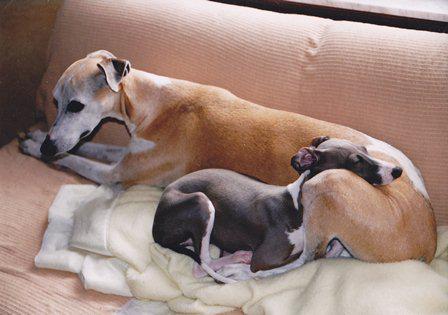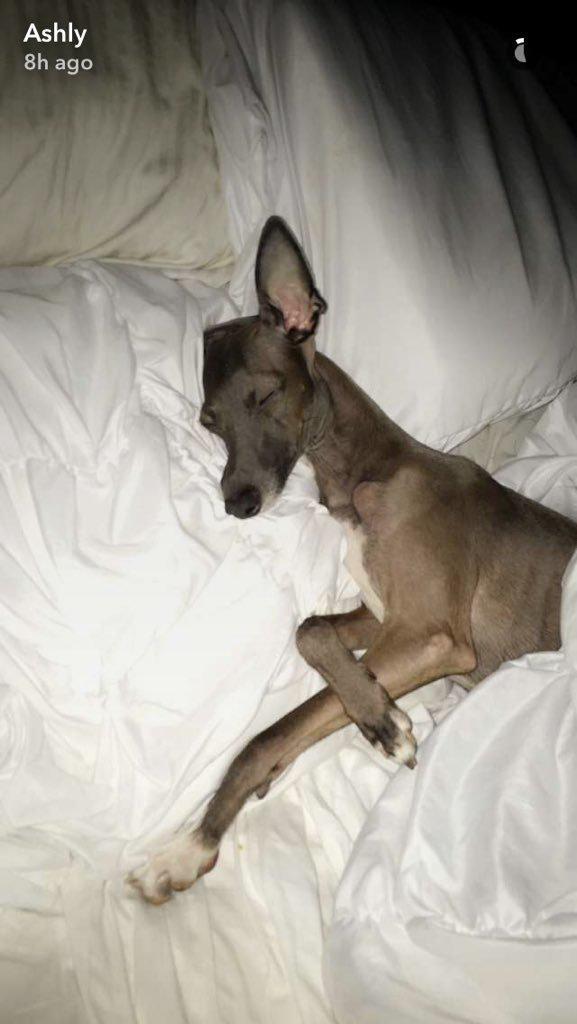The first image is the image on the left, the second image is the image on the right. Considering the images on both sides, is "There are a total of three dogs." valid? Answer yes or no. Yes. The first image is the image on the left, the second image is the image on the right. Examine the images to the left and right. Is the description "A dog is sleeping with another dog in at least one picture." accurate? Answer yes or no. Yes. 